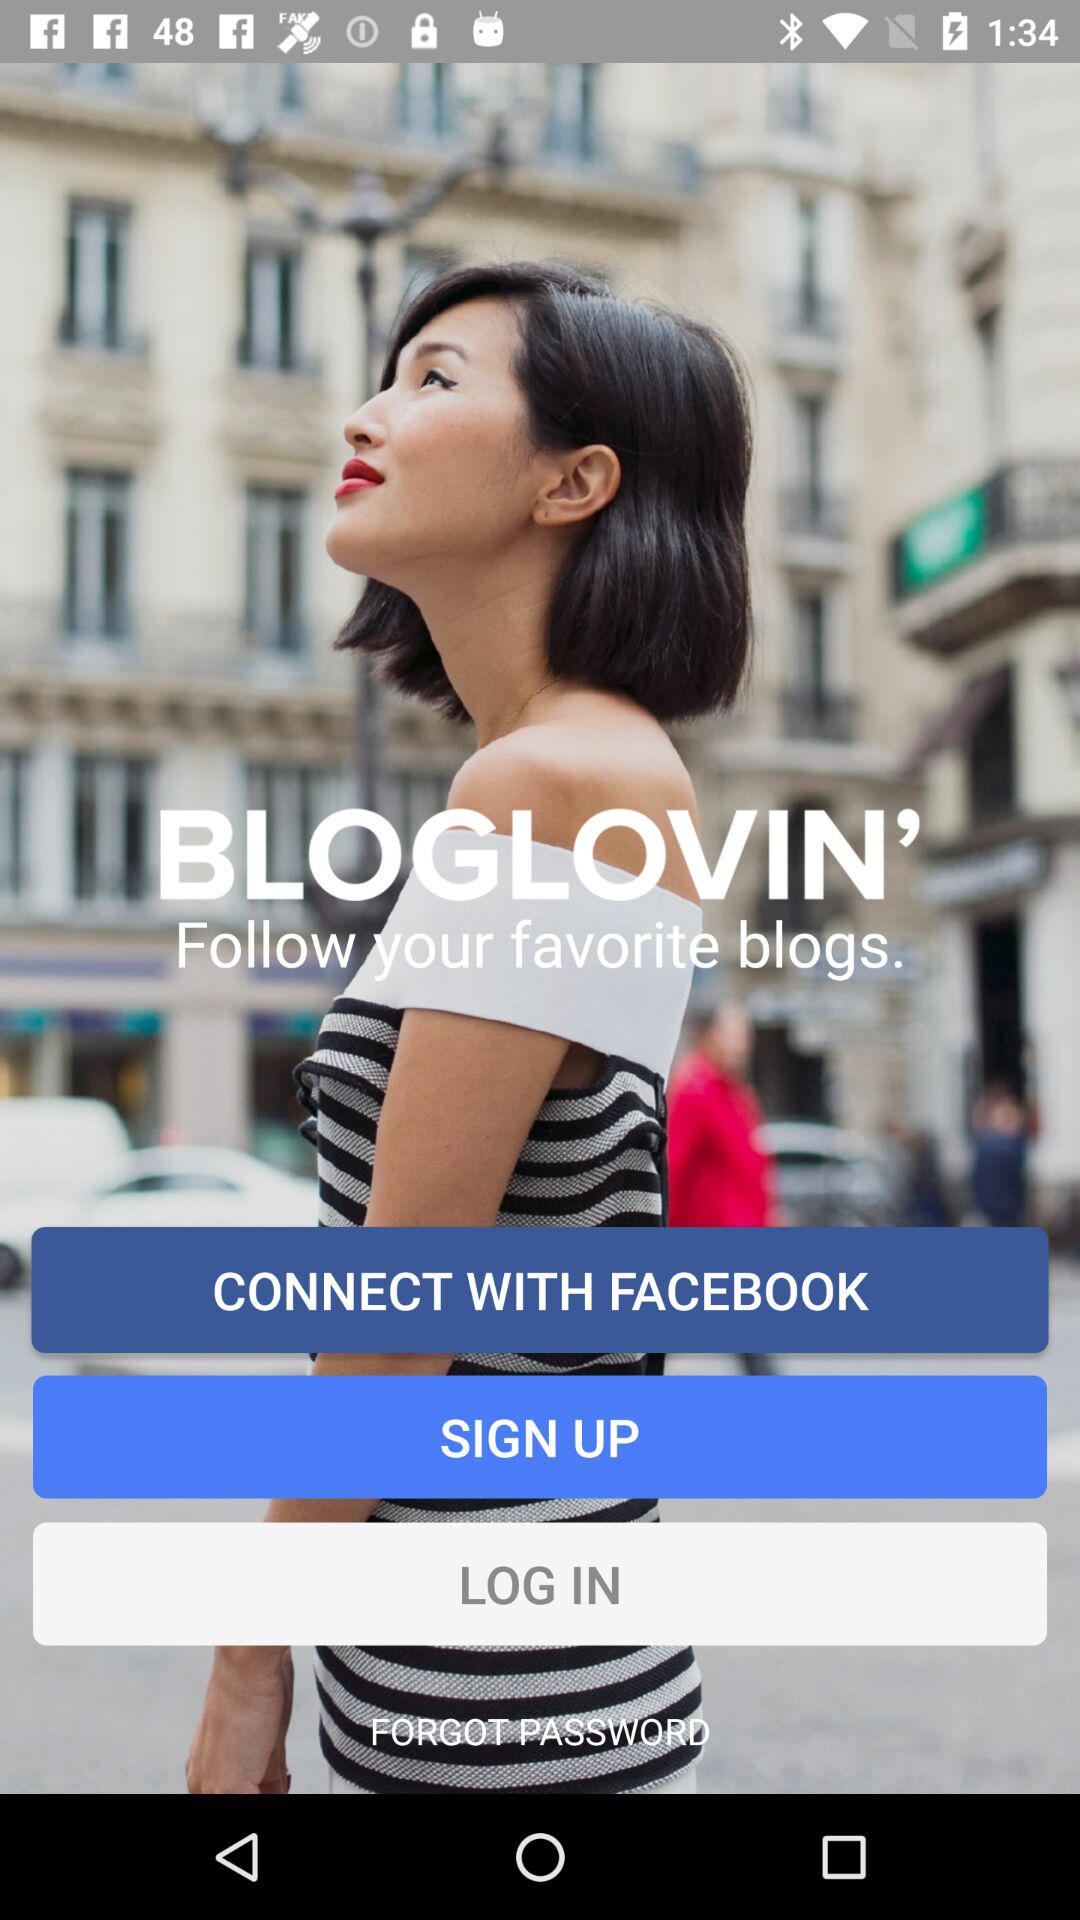Through what account can the user connect? The user can connect through the "FACEBOOK" account. 